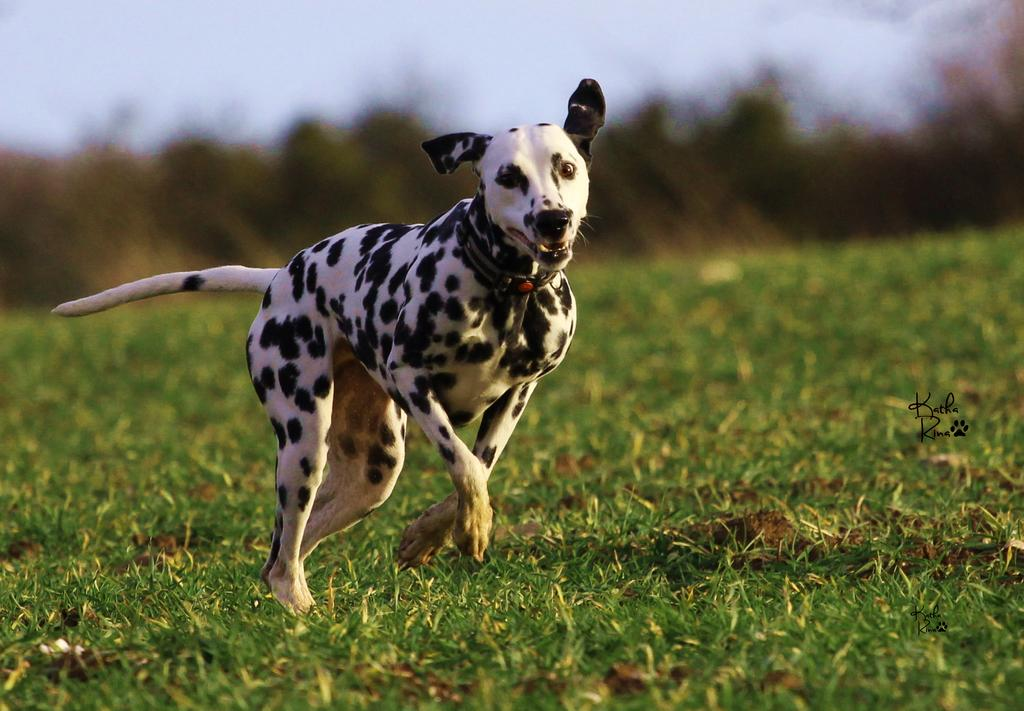What type of animal is in the image? There is a dalmatian in the image. What is the dalmatian doing in the image? The dalmatian is running on the ground. What is the surface that the dalmatian is running on? The ground is covered with grass. Can you describe the background of the image? The background of the image is blurry. What type of peace symbol can be seen in the image? There is no peace symbol present in the image; it features a dalmatian running on grass. How many books are visible in the image? There are no books present in the image. 